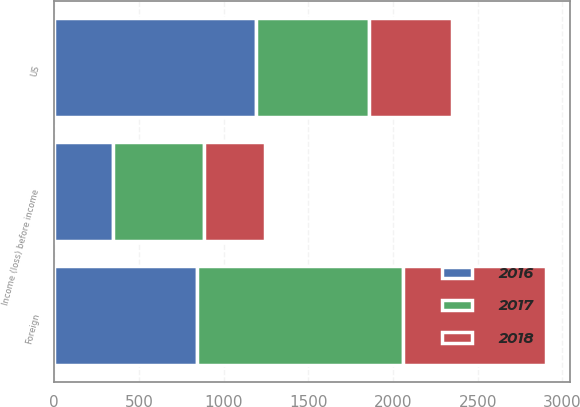<chart> <loc_0><loc_0><loc_500><loc_500><stacked_bar_chart><ecel><fcel>US<fcel>Foreign<fcel>Income (loss) before income<nl><fcel>2017<fcel>672<fcel>1213<fcel>541<nl><fcel>2016<fcel>1189<fcel>843<fcel>346<nl><fcel>2018<fcel>487<fcel>845<fcel>358<nl></chart> 